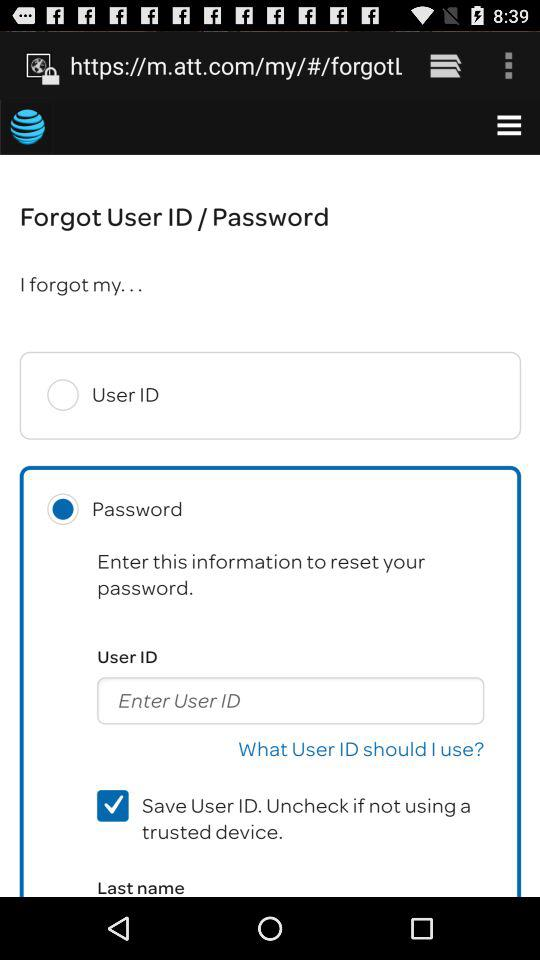What is the status of the "Save User ID"? The status is on. 